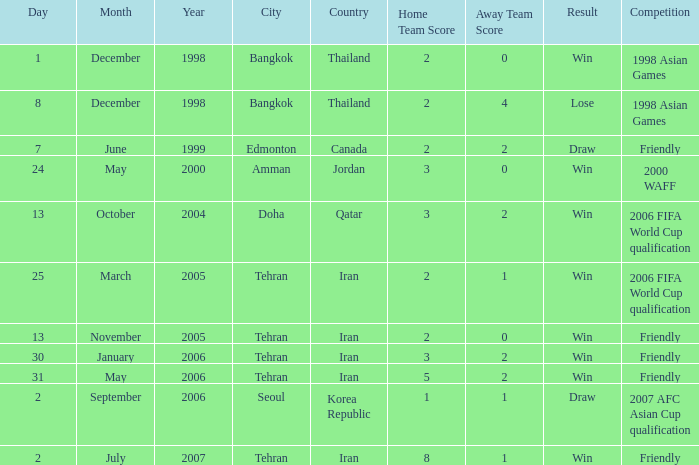What was the competition on 7 June 1999? Friendly. 